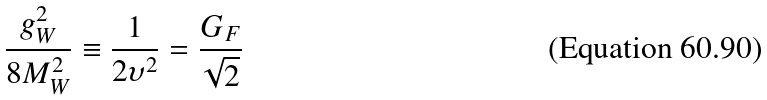Convert formula to latex. <formula><loc_0><loc_0><loc_500><loc_500>\frac { g _ { W } ^ { 2 } } { 8 M _ { W } ^ { 2 } } \equiv \frac { 1 } { 2 \upsilon ^ { 2 } } = \frac { G _ { F } } { \sqrt { 2 } }</formula> 